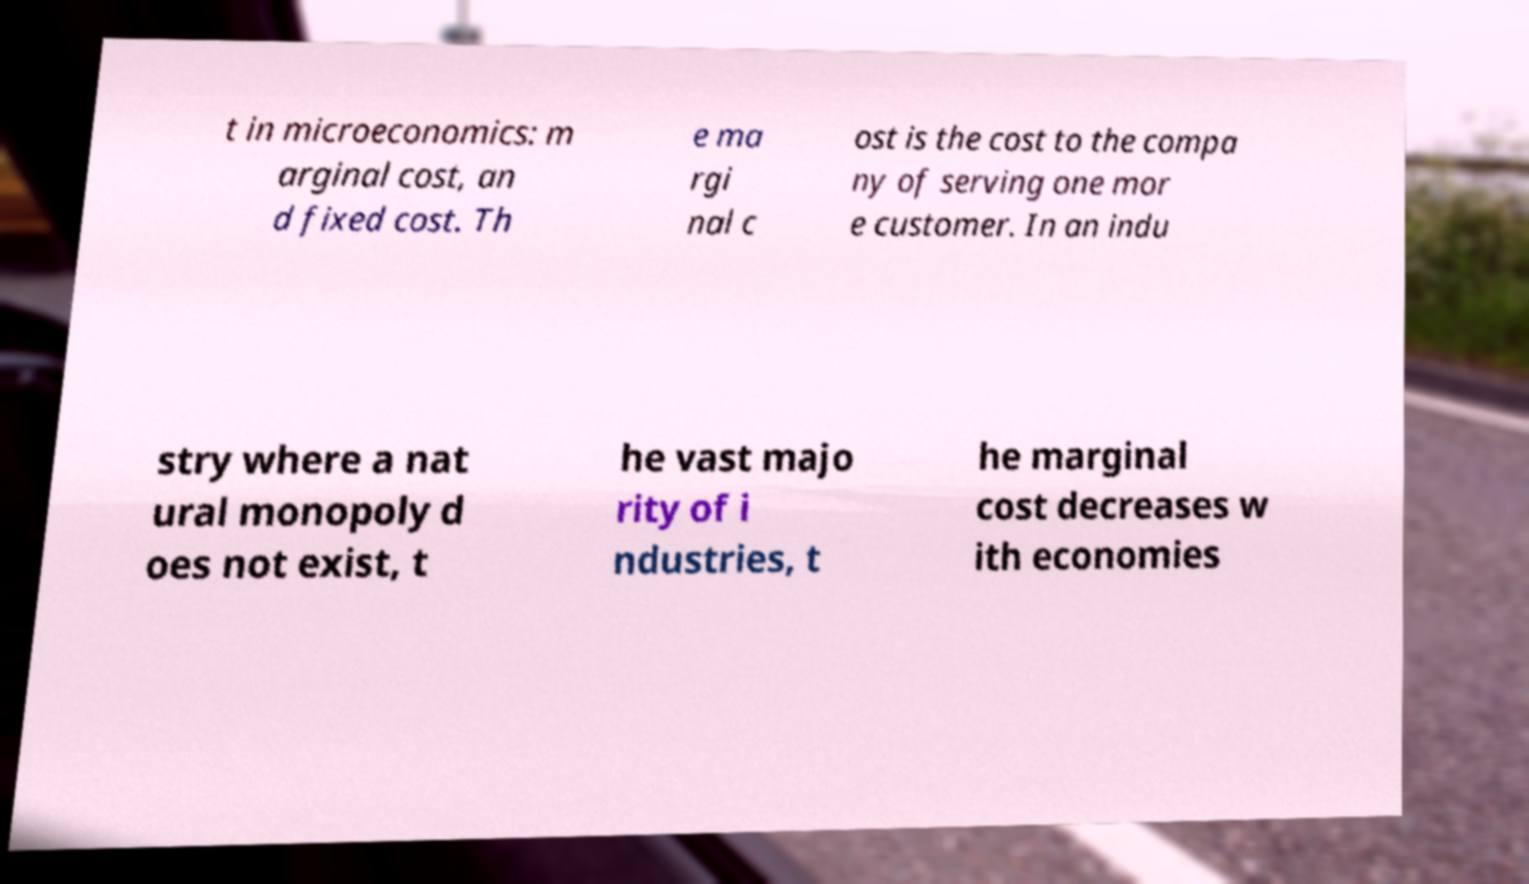I need the written content from this picture converted into text. Can you do that? t in microeconomics: m arginal cost, an d fixed cost. Th e ma rgi nal c ost is the cost to the compa ny of serving one mor e customer. In an indu stry where a nat ural monopoly d oes not exist, t he vast majo rity of i ndustries, t he marginal cost decreases w ith economies 